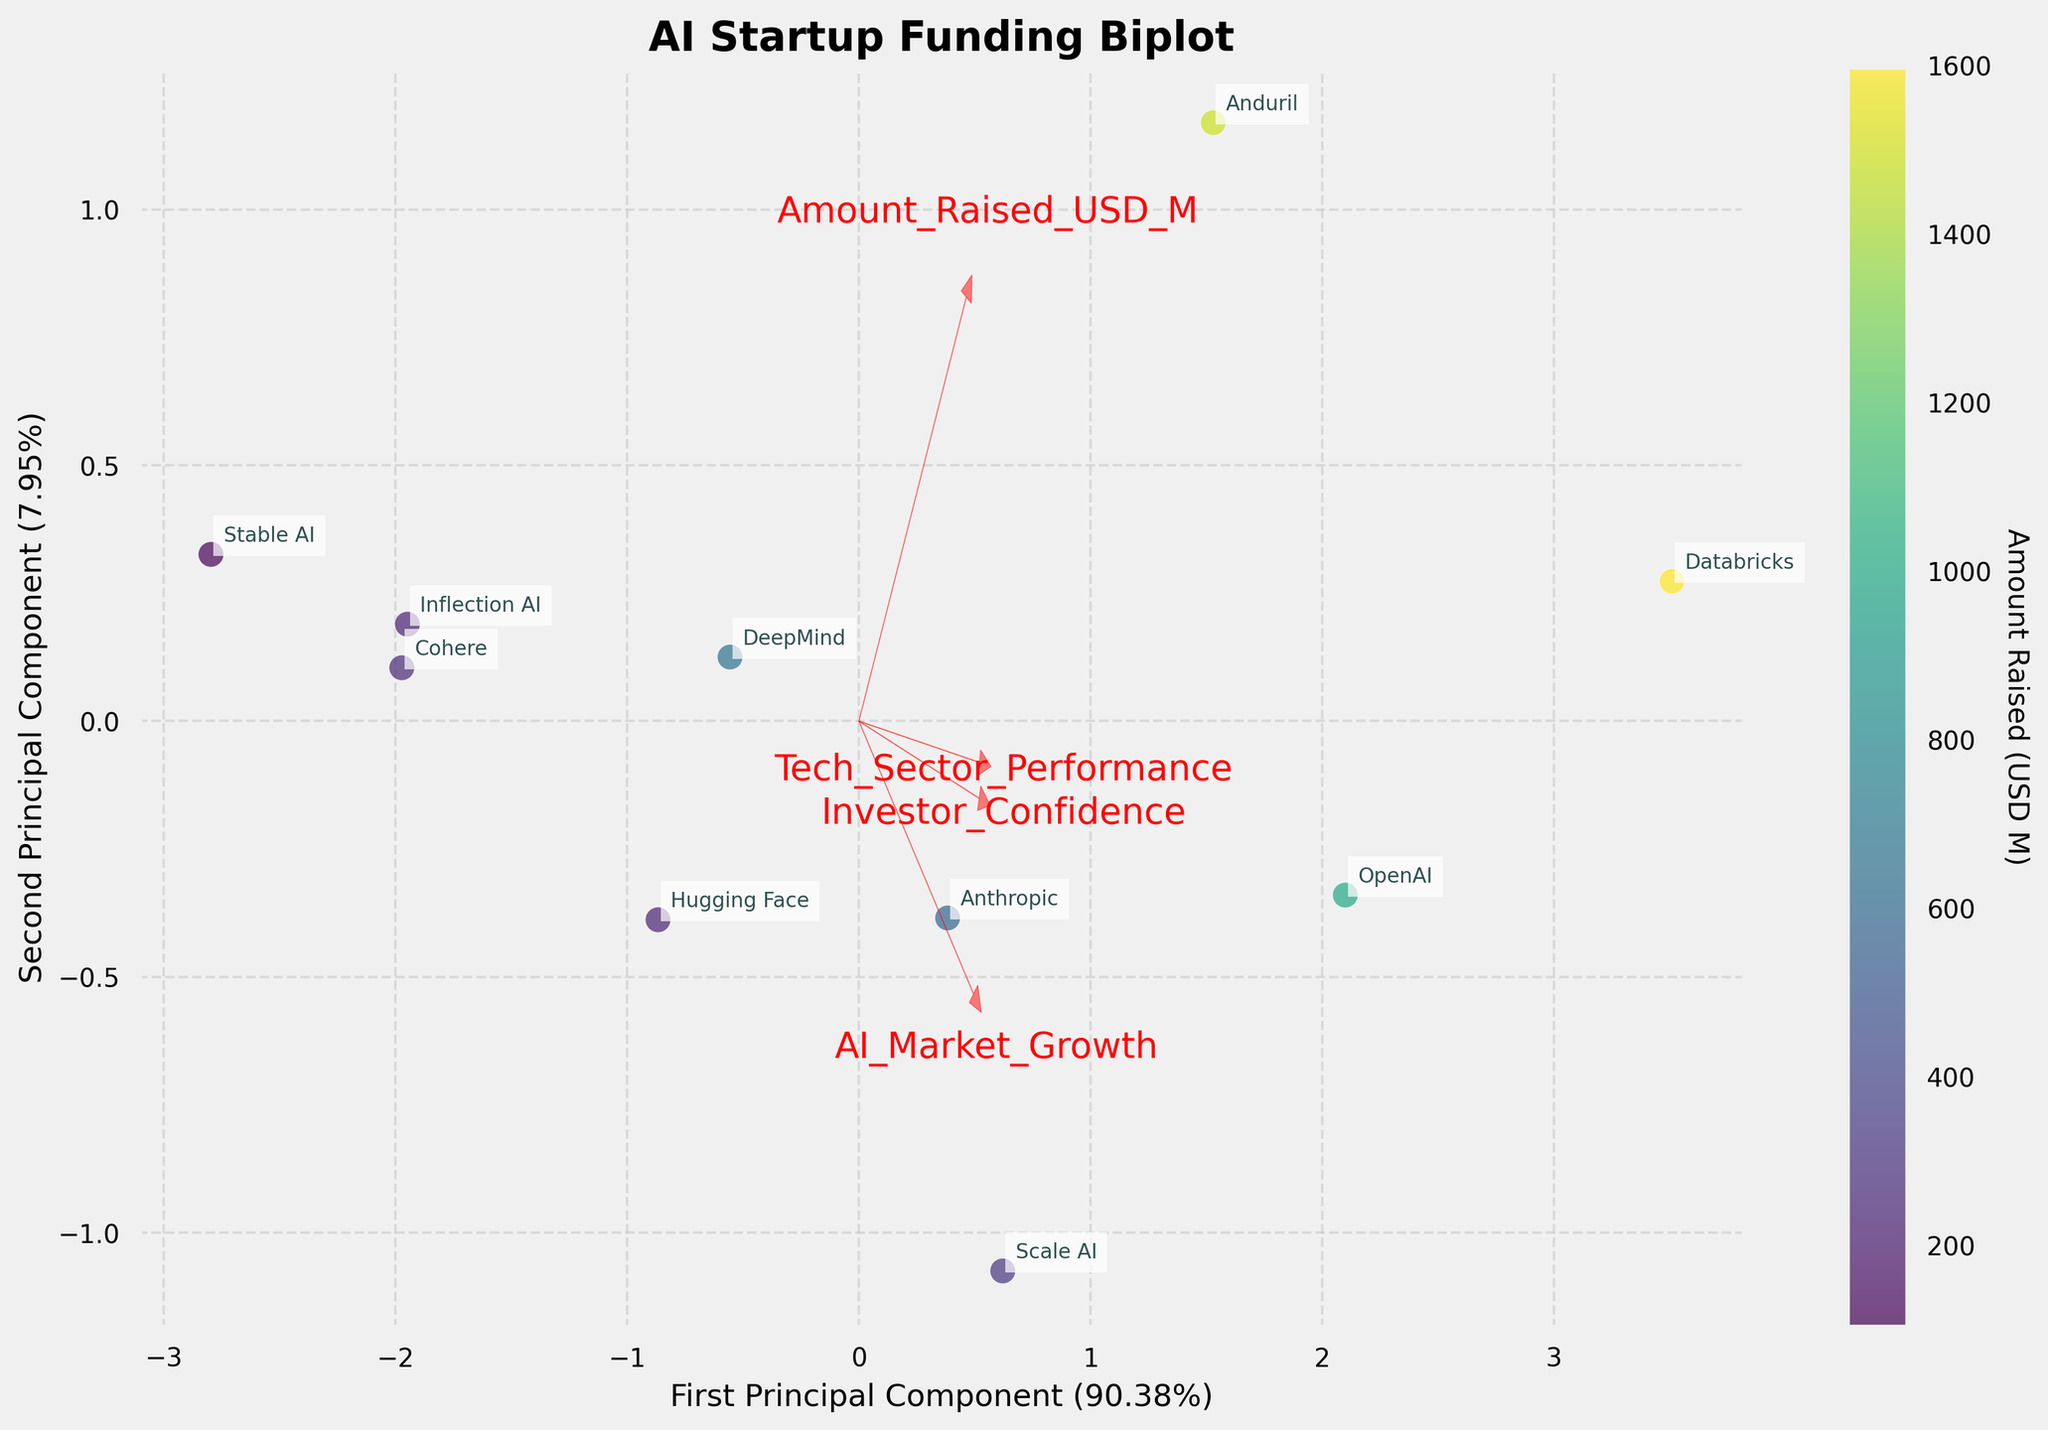What is the title of the biplot? The title is written at the top of the biplot and it states the overall subject of the plot.
Answer: AI Startup Funding Biplot How many companies are displayed in the biplot? Count the number of unique labels (company names) on the plot. There should be ten individual company names.
Answer: Ten companies What feature corresponds to the largest arrow in the biplot? The largest arrow in the biplot represents the feature with the greatest influence on the principal components.
Answer: Amount Raised (USD M) Which company raised the highest amount of funding? Identify the data point corresponding to the highest "Amount Raised (USD M)" and find the company label next to it.
Answer: Databricks Among the features, which two are most similar in terms of their loading vectors? Compare the angles between the arrows (loading vectors) representing the features. The two arrows that are closest together represent the most similar features.
Answer: AI Market Growth and Investor Confidence How much variance is explained by the first principal component? Read the percentage next to the x-axis label, which indicates the variance explained by the first principal component.
Answer: 57.60% Which company is located closest to the origin of the plot? Find the company label that is nearest to the intersection of the x-axis and y-axis.
Answer: Stable AI How does Tech Sector Performance relate to the first principal component? Look at the direction of the arrow representing Tech Sector Performance and see how it aligns with the first principal component axis.
Answer: Positively correlated Which company is most strongly associated with high investor confidence? Identify the company that is located furthest in the direction of the "Investor Confidence" arrow.
Answer: Databricks How does the correlation between AI Market Growth and the second principal component compare to that with the first principal component? Observe the angle and length of the arrow representing AI Market Growth in relation to both principal components. The extent to which it aligns with each axis indicates the correlation.
Answer: More strongly correlated with the first principal component 